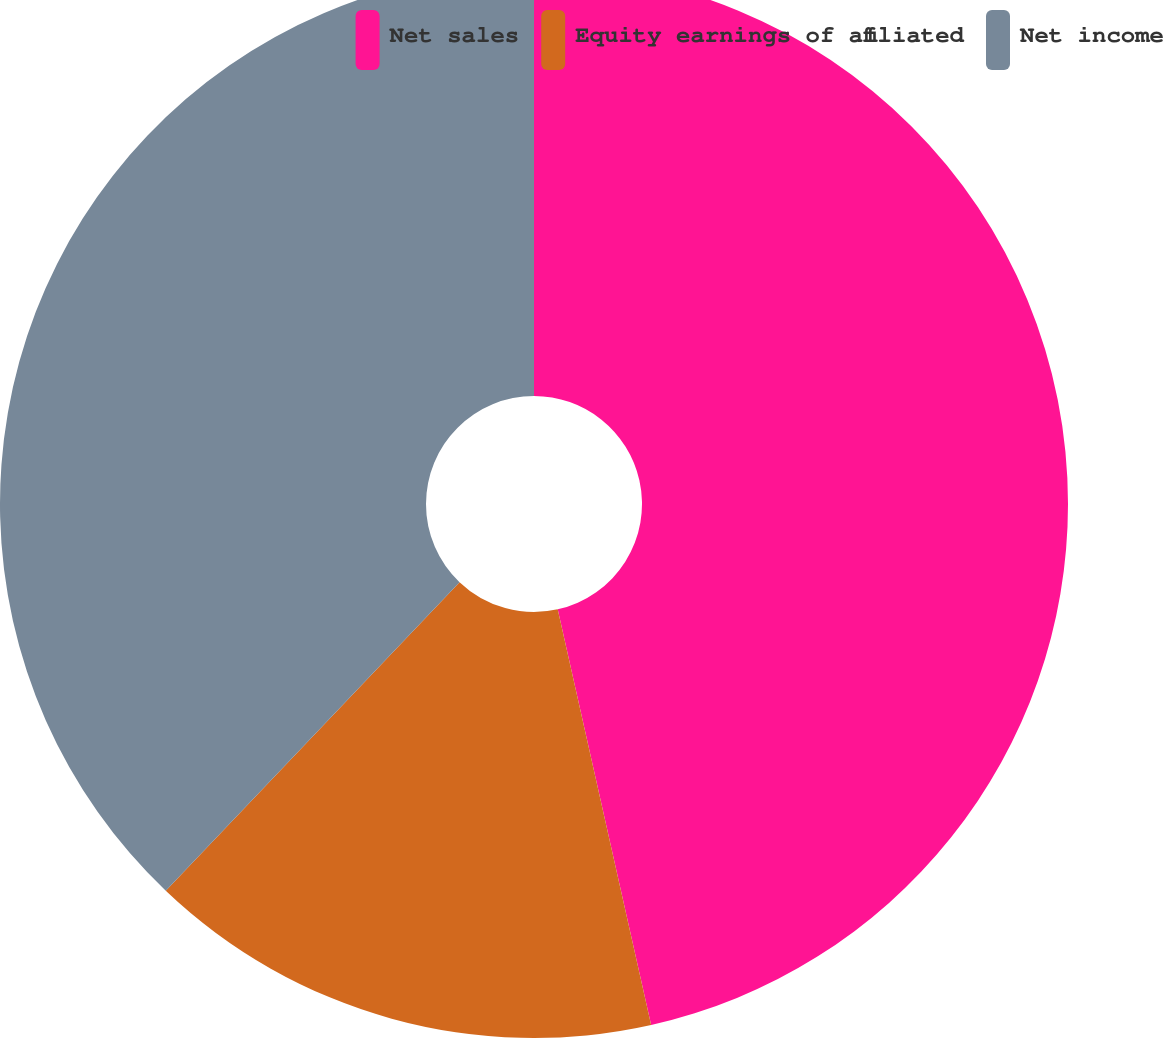Convert chart. <chart><loc_0><loc_0><loc_500><loc_500><pie_chart><fcel>Net sales<fcel>Equity earnings of affiliated<fcel>Net income<nl><fcel>46.48%<fcel>15.63%<fcel>37.89%<nl></chart> 